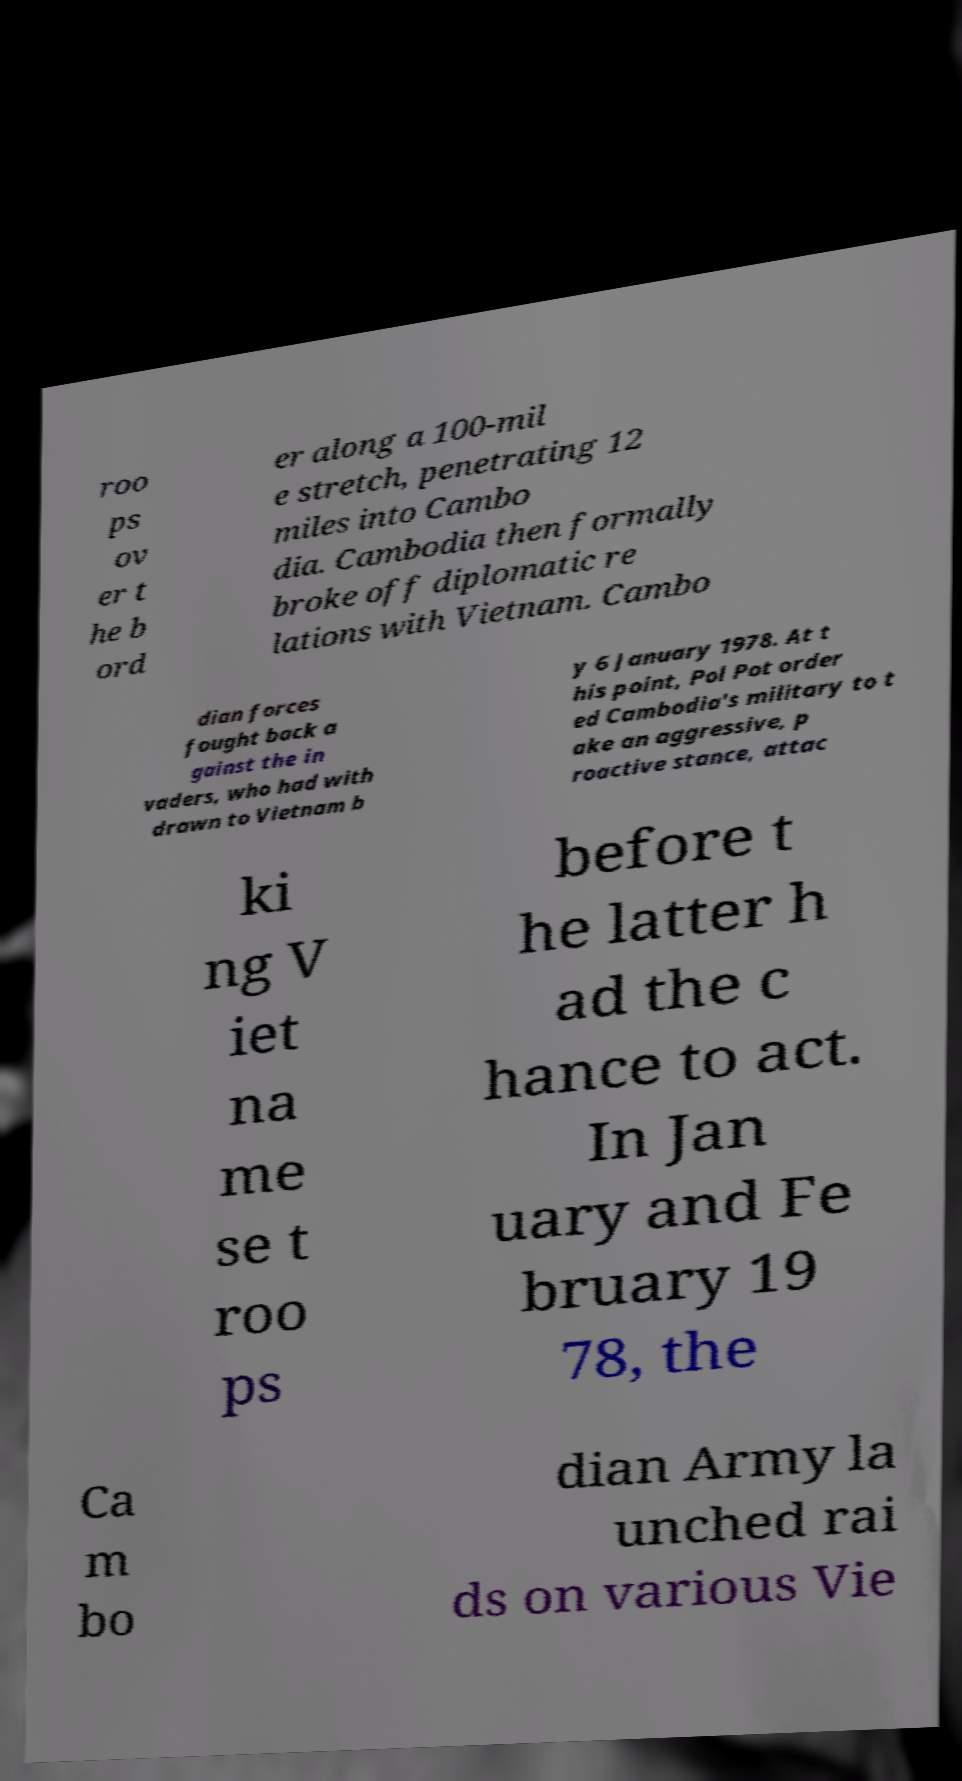Can you read and provide the text displayed in the image?This photo seems to have some interesting text. Can you extract and type it out for me? roo ps ov er t he b ord er along a 100-mil e stretch, penetrating 12 miles into Cambo dia. Cambodia then formally broke off diplomatic re lations with Vietnam. Cambo dian forces fought back a gainst the in vaders, who had with drawn to Vietnam b y 6 January 1978. At t his point, Pol Pot order ed Cambodia's military to t ake an aggressive, p roactive stance, attac ki ng V iet na me se t roo ps before t he latter h ad the c hance to act. In Jan uary and Fe bruary 19 78, the Ca m bo dian Army la unched rai ds on various Vie 